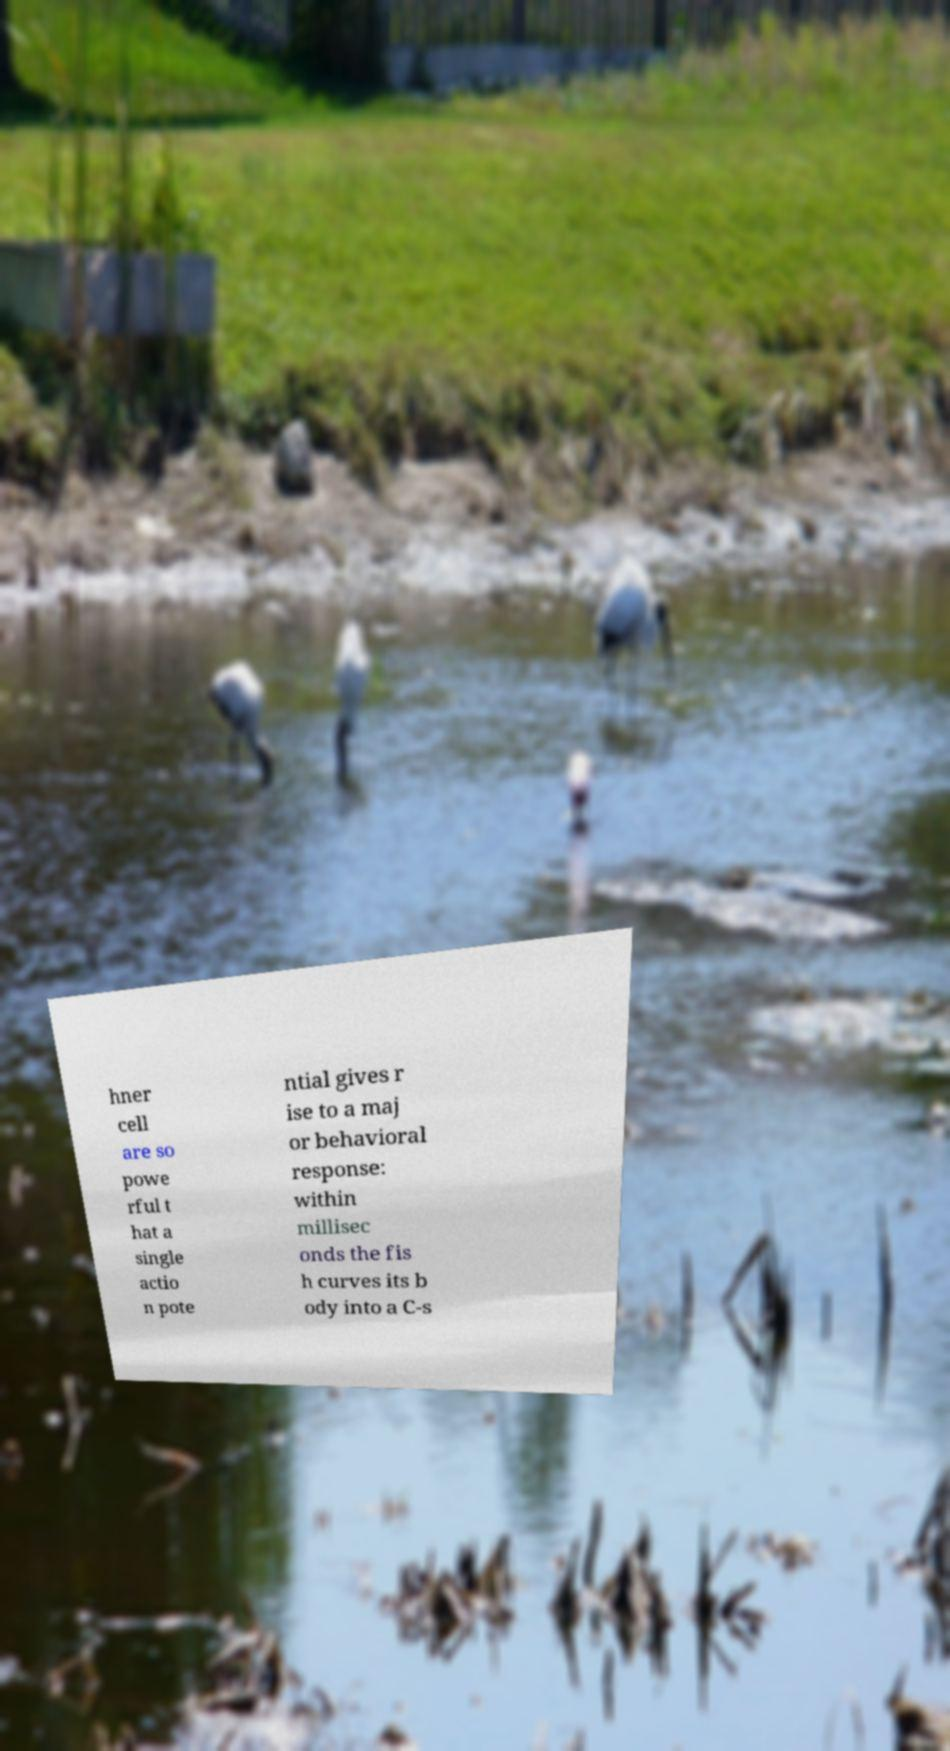Could you extract and type out the text from this image? hner cell are so powe rful t hat a single actio n pote ntial gives r ise to a maj or behavioral response: within millisec onds the fis h curves its b ody into a C-s 